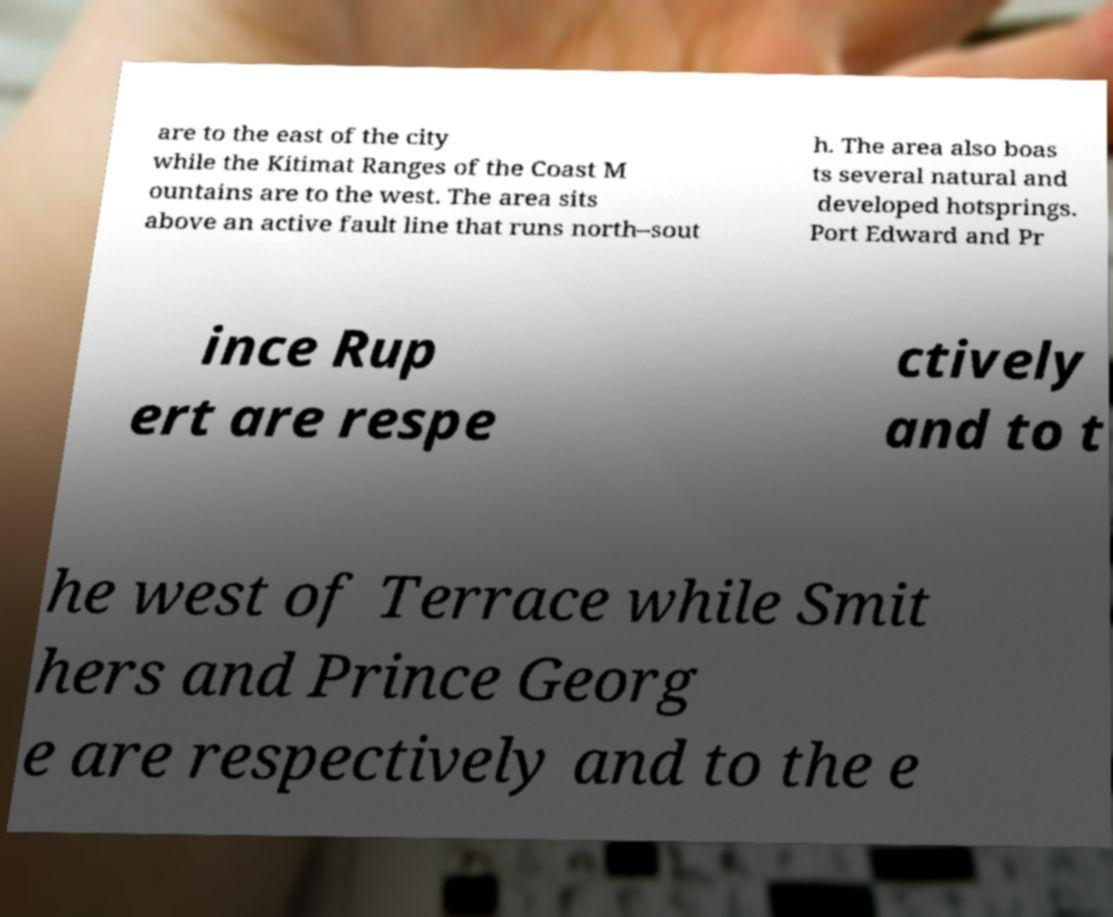Please read and relay the text visible in this image. What does it say? are to the east of the city while the Kitimat Ranges of the Coast M ountains are to the west. The area sits above an active fault line that runs north–sout h. The area also boas ts several natural and developed hotsprings. Port Edward and Pr ince Rup ert are respe ctively and to t he west of Terrace while Smit hers and Prince Georg e are respectively and to the e 